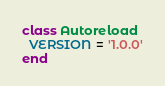<code> <loc_0><loc_0><loc_500><loc_500><_Ruby_>class Autoreload
  VERSION = '1.0.0'
end</code> 